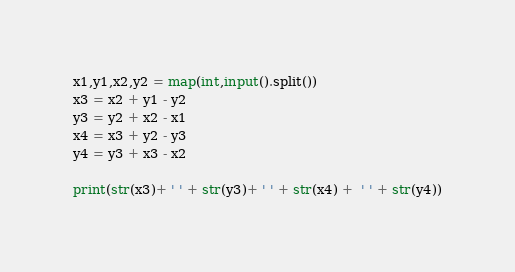<code> <loc_0><loc_0><loc_500><loc_500><_Python_>x1,y1,x2,y2 = map(int,input().split())
x3 = x2 + y1 - y2
y3 = y2 + x2 - x1 
x4 = x3 + y2 - y3
y4 = y3 + x3 - x2 

print(str(x3)+ ' ' + str(y3)+ ' ' + str(x4) +  ' ' + str(y4))</code> 